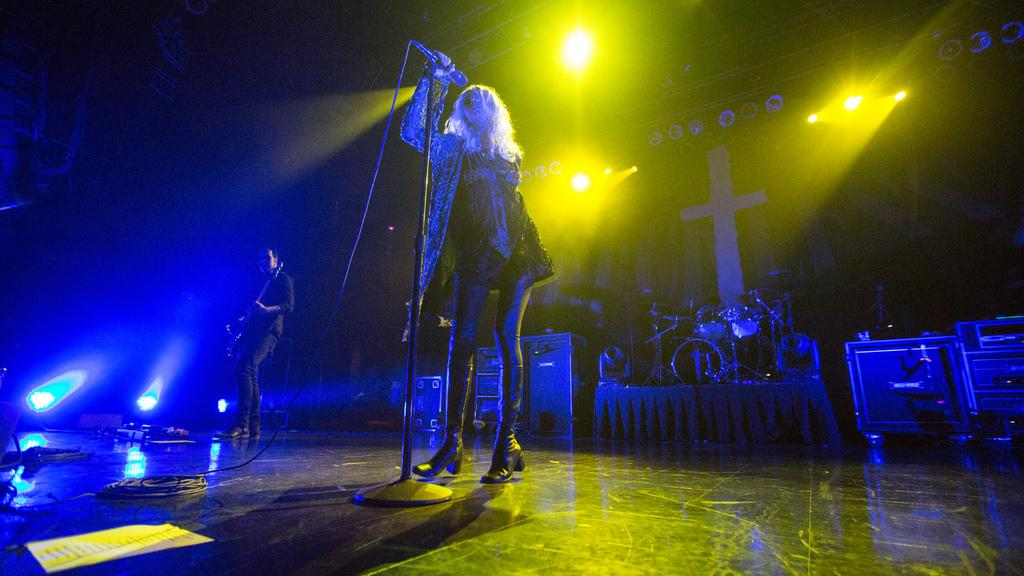What is the woman in the center of the image holding? The woman is holding a microphone in the center of the image. What is the man in the left center of the image holding? The man is holding a guitar in the left center of the image. What can be seen in the background of the image? There are musical instruments, a wall, and lights in the background of the image. What type of tub is visible in the image? There is no tub present in the image. 